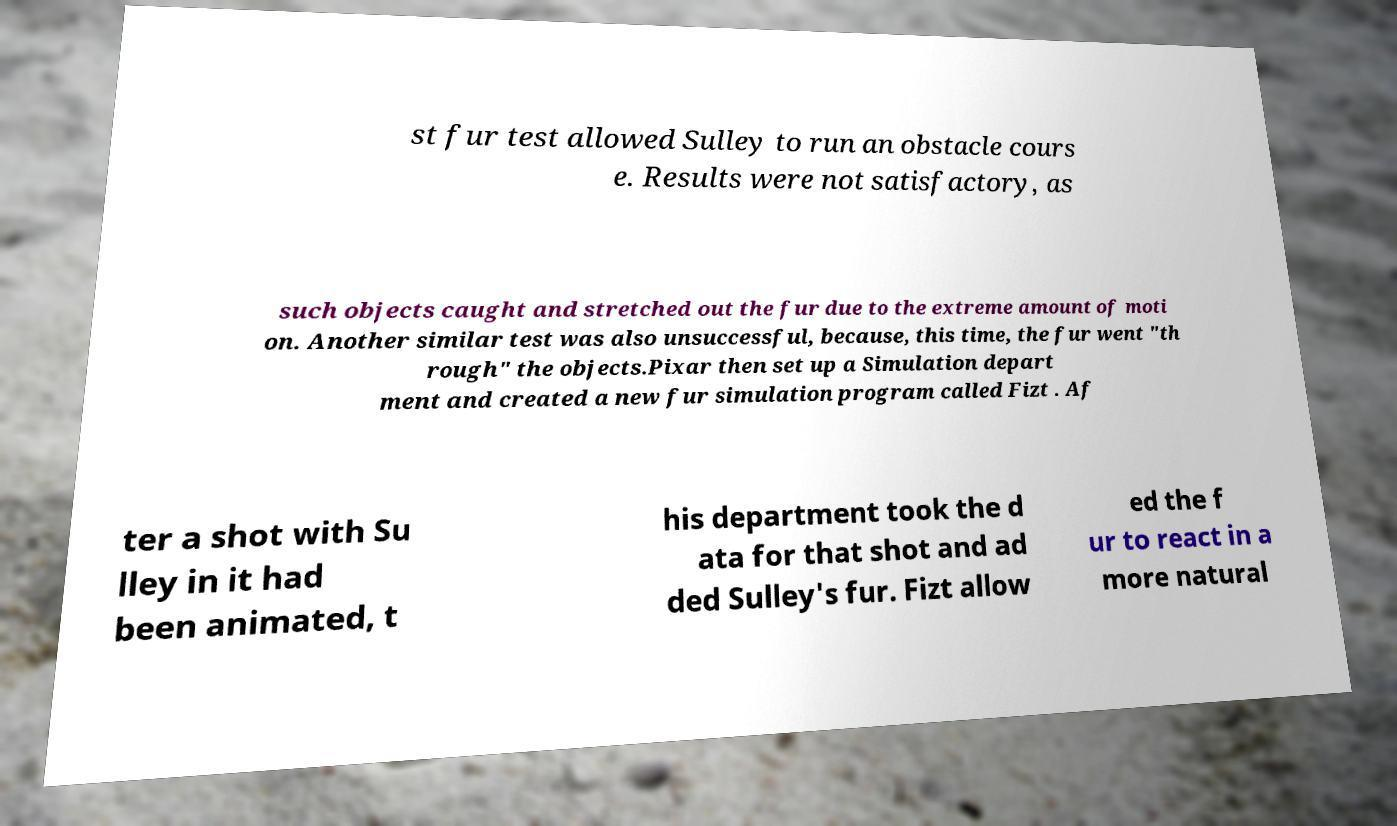Can you read and provide the text displayed in the image?This photo seems to have some interesting text. Can you extract and type it out for me? st fur test allowed Sulley to run an obstacle cours e. Results were not satisfactory, as such objects caught and stretched out the fur due to the extreme amount of moti on. Another similar test was also unsuccessful, because, this time, the fur went "th rough" the objects.Pixar then set up a Simulation depart ment and created a new fur simulation program called Fizt . Af ter a shot with Su lley in it had been animated, t his department took the d ata for that shot and ad ded Sulley's fur. Fizt allow ed the f ur to react in a more natural 